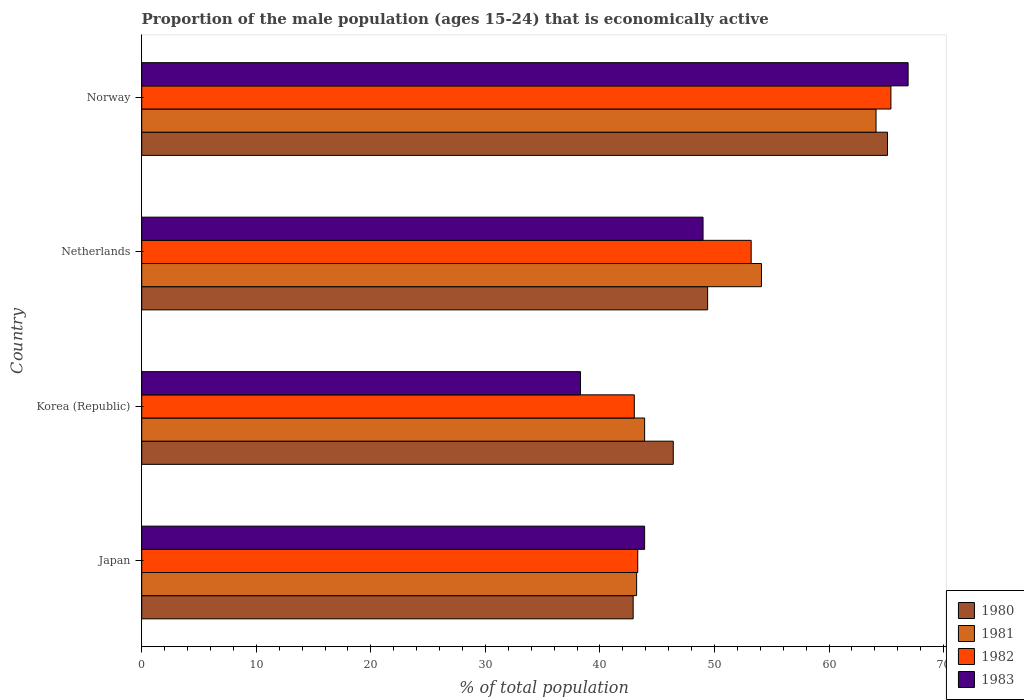How many groups of bars are there?
Keep it short and to the point. 4. How many bars are there on the 4th tick from the top?
Your answer should be compact. 4. How many bars are there on the 1st tick from the bottom?
Make the answer very short. 4. What is the label of the 4th group of bars from the top?
Offer a terse response. Japan. What is the proportion of the male population that is economically active in 1982 in Korea (Republic)?
Your answer should be very brief. 43. Across all countries, what is the maximum proportion of the male population that is economically active in 1983?
Offer a very short reply. 66.9. Across all countries, what is the minimum proportion of the male population that is economically active in 1982?
Offer a terse response. 43. In which country was the proportion of the male population that is economically active in 1980 maximum?
Your answer should be very brief. Norway. In which country was the proportion of the male population that is economically active in 1981 minimum?
Your answer should be very brief. Japan. What is the total proportion of the male population that is economically active in 1980 in the graph?
Make the answer very short. 203.8. What is the difference between the proportion of the male population that is economically active in 1982 in Japan and that in Netherlands?
Ensure brevity in your answer.  -9.9. What is the difference between the proportion of the male population that is economically active in 1983 in Korea (Republic) and the proportion of the male population that is economically active in 1980 in Netherlands?
Provide a short and direct response. -11.1. What is the average proportion of the male population that is economically active in 1983 per country?
Your answer should be very brief. 49.53. What is the difference between the proportion of the male population that is economically active in 1981 and proportion of the male population that is economically active in 1980 in Korea (Republic)?
Provide a succinct answer. -2.5. What is the ratio of the proportion of the male population that is economically active in 1981 in Japan to that in Korea (Republic)?
Your answer should be compact. 0.98. Is the difference between the proportion of the male population that is economically active in 1981 in Korea (Republic) and Norway greater than the difference between the proportion of the male population that is economically active in 1980 in Korea (Republic) and Norway?
Provide a succinct answer. No. What is the difference between the highest and the second highest proportion of the male population that is economically active in 1980?
Keep it short and to the point. 15.7. What is the difference between the highest and the lowest proportion of the male population that is economically active in 1981?
Ensure brevity in your answer.  20.9. Is the sum of the proportion of the male population that is economically active in 1981 in Korea (Republic) and Netherlands greater than the maximum proportion of the male population that is economically active in 1980 across all countries?
Your answer should be very brief. Yes. Is it the case that in every country, the sum of the proportion of the male population that is economically active in 1982 and proportion of the male population that is economically active in 1983 is greater than the sum of proportion of the male population that is economically active in 1981 and proportion of the male population that is economically active in 1980?
Offer a very short reply. No. What is the difference between two consecutive major ticks on the X-axis?
Keep it short and to the point. 10. Are the values on the major ticks of X-axis written in scientific E-notation?
Offer a terse response. No. Does the graph contain any zero values?
Offer a very short reply. No. Does the graph contain grids?
Provide a succinct answer. No. How are the legend labels stacked?
Offer a very short reply. Vertical. What is the title of the graph?
Your answer should be very brief. Proportion of the male population (ages 15-24) that is economically active. What is the label or title of the X-axis?
Keep it short and to the point. % of total population. What is the label or title of the Y-axis?
Provide a succinct answer. Country. What is the % of total population in 1980 in Japan?
Your answer should be compact. 42.9. What is the % of total population in 1981 in Japan?
Provide a succinct answer. 43.2. What is the % of total population in 1982 in Japan?
Provide a succinct answer. 43.3. What is the % of total population of 1983 in Japan?
Keep it short and to the point. 43.9. What is the % of total population of 1980 in Korea (Republic)?
Keep it short and to the point. 46.4. What is the % of total population of 1981 in Korea (Republic)?
Your answer should be very brief. 43.9. What is the % of total population in 1982 in Korea (Republic)?
Provide a short and direct response. 43. What is the % of total population in 1983 in Korea (Republic)?
Your response must be concise. 38.3. What is the % of total population of 1980 in Netherlands?
Provide a short and direct response. 49.4. What is the % of total population in 1981 in Netherlands?
Your answer should be compact. 54.1. What is the % of total population in 1982 in Netherlands?
Make the answer very short. 53.2. What is the % of total population of 1983 in Netherlands?
Provide a short and direct response. 49. What is the % of total population in 1980 in Norway?
Provide a short and direct response. 65.1. What is the % of total population in 1981 in Norway?
Keep it short and to the point. 64.1. What is the % of total population in 1982 in Norway?
Offer a very short reply. 65.4. What is the % of total population of 1983 in Norway?
Offer a terse response. 66.9. Across all countries, what is the maximum % of total population of 1980?
Offer a terse response. 65.1. Across all countries, what is the maximum % of total population of 1981?
Keep it short and to the point. 64.1. Across all countries, what is the maximum % of total population in 1982?
Make the answer very short. 65.4. Across all countries, what is the maximum % of total population in 1983?
Make the answer very short. 66.9. Across all countries, what is the minimum % of total population in 1980?
Ensure brevity in your answer.  42.9. Across all countries, what is the minimum % of total population of 1981?
Provide a succinct answer. 43.2. Across all countries, what is the minimum % of total population in 1982?
Give a very brief answer. 43. Across all countries, what is the minimum % of total population of 1983?
Provide a succinct answer. 38.3. What is the total % of total population in 1980 in the graph?
Your response must be concise. 203.8. What is the total % of total population in 1981 in the graph?
Offer a very short reply. 205.3. What is the total % of total population in 1982 in the graph?
Your response must be concise. 204.9. What is the total % of total population of 1983 in the graph?
Offer a very short reply. 198.1. What is the difference between the % of total population in 1980 in Japan and that in Korea (Republic)?
Give a very brief answer. -3.5. What is the difference between the % of total population in 1982 in Japan and that in Korea (Republic)?
Your answer should be very brief. 0.3. What is the difference between the % of total population of 1980 in Japan and that in Netherlands?
Make the answer very short. -6.5. What is the difference between the % of total population in 1981 in Japan and that in Netherlands?
Your answer should be very brief. -10.9. What is the difference between the % of total population of 1983 in Japan and that in Netherlands?
Provide a short and direct response. -5.1. What is the difference between the % of total population in 1980 in Japan and that in Norway?
Your response must be concise. -22.2. What is the difference between the % of total population in 1981 in Japan and that in Norway?
Give a very brief answer. -20.9. What is the difference between the % of total population in 1982 in Japan and that in Norway?
Offer a terse response. -22.1. What is the difference between the % of total population in 1983 in Japan and that in Norway?
Give a very brief answer. -23. What is the difference between the % of total population in 1980 in Korea (Republic) and that in Netherlands?
Your answer should be very brief. -3. What is the difference between the % of total population in 1980 in Korea (Republic) and that in Norway?
Ensure brevity in your answer.  -18.7. What is the difference between the % of total population of 1981 in Korea (Republic) and that in Norway?
Your response must be concise. -20.2. What is the difference between the % of total population of 1982 in Korea (Republic) and that in Norway?
Your response must be concise. -22.4. What is the difference between the % of total population of 1983 in Korea (Republic) and that in Norway?
Ensure brevity in your answer.  -28.6. What is the difference between the % of total population in 1980 in Netherlands and that in Norway?
Your answer should be very brief. -15.7. What is the difference between the % of total population in 1981 in Netherlands and that in Norway?
Provide a short and direct response. -10. What is the difference between the % of total population in 1982 in Netherlands and that in Norway?
Provide a short and direct response. -12.2. What is the difference between the % of total population in 1983 in Netherlands and that in Norway?
Your answer should be compact. -17.9. What is the difference between the % of total population in 1980 in Japan and the % of total population in 1982 in Korea (Republic)?
Ensure brevity in your answer.  -0.1. What is the difference between the % of total population of 1980 in Japan and the % of total population of 1981 in Netherlands?
Give a very brief answer. -11.2. What is the difference between the % of total population of 1980 in Japan and the % of total population of 1982 in Netherlands?
Give a very brief answer. -10.3. What is the difference between the % of total population of 1982 in Japan and the % of total population of 1983 in Netherlands?
Keep it short and to the point. -5.7. What is the difference between the % of total population of 1980 in Japan and the % of total population of 1981 in Norway?
Provide a short and direct response. -21.2. What is the difference between the % of total population in 1980 in Japan and the % of total population in 1982 in Norway?
Your response must be concise. -22.5. What is the difference between the % of total population in 1981 in Japan and the % of total population in 1982 in Norway?
Your response must be concise. -22.2. What is the difference between the % of total population of 1981 in Japan and the % of total population of 1983 in Norway?
Your response must be concise. -23.7. What is the difference between the % of total population in 1982 in Japan and the % of total population in 1983 in Norway?
Your response must be concise. -23.6. What is the difference between the % of total population in 1980 in Korea (Republic) and the % of total population in 1981 in Netherlands?
Provide a succinct answer. -7.7. What is the difference between the % of total population in 1980 in Korea (Republic) and the % of total population in 1982 in Netherlands?
Keep it short and to the point. -6.8. What is the difference between the % of total population in 1981 in Korea (Republic) and the % of total population in 1982 in Netherlands?
Your answer should be very brief. -9.3. What is the difference between the % of total population in 1982 in Korea (Republic) and the % of total population in 1983 in Netherlands?
Keep it short and to the point. -6. What is the difference between the % of total population of 1980 in Korea (Republic) and the % of total population of 1981 in Norway?
Keep it short and to the point. -17.7. What is the difference between the % of total population of 1980 in Korea (Republic) and the % of total population of 1983 in Norway?
Provide a succinct answer. -20.5. What is the difference between the % of total population of 1981 in Korea (Republic) and the % of total population of 1982 in Norway?
Make the answer very short. -21.5. What is the difference between the % of total population in 1982 in Korea (Republic) and the % of total population in 1983 in Norway?
Offer a terse response. -23.9. What is the difference between the % of total population in 1980 in Netherlands and the % of total population in 1981 in Norway?
Ensure brevity in your answer.  -14.7. What is the difference between the % of total population of 1980 in Netherlands and the % of total population of 1982 in Norway?
Your answer should be very brief. -16. What is the difference between the % of total population of 1980 in Netherlands and the % of total population of 1983 in Norway?
Ensure brevity in your answer.  -17.5. What is the difference between the % of total population in 1982 in Netherlands and the % of total population in 1983 in Norway?
Your answer should be compact. -13.7. What is the average % of total population of 1980 per country?
Offer a terse response. 50.95. What is the average % of total population in 1981 per country?
Your answer should be very brief. 51.33. What is the average % of total population of 1982 per country?
Your response must be concise. 51.23. What is the average % of total population in 1983 per country?
Provide a succinct answer. 49.52. What is the difference between the % of total population of 1980 and % of total population of 1981 in Japan?
Provide a short and direct response. -0.3. What is the difference between the % of total population in 1980 and % of total population in 1982 in Japan?
Provide a succinct answer. -0.4. What is the difference between the % of total population in 1980 and % of total population in 1983 in Japan?
Ensure brevity in your answer.  -1. What is the difference between the % of total population of 1981 and % of total population of 1982 in Japan?
Make the answer very short. -0.1. What is the difference between the % of total population in 1980 and % of total population in 1981 in Korea (Republic)?
Give a very brief answer. 2.5. What is the difference between the % of total population of 1980 and % of total population of 1983 in Korea (Republic)?
Provide a succinct answer. 8.1. What is the difference between the % of total population of 1981 and % of total population of 1983 in Korea (Republic)?
Give a very brief answer. 5.6. What is the difference between the % of total population of 1982 and % of total population of 1983 in Korea (Republic)?
Provide a succinct answer. 4.7. What is the difference between the % of total population of 1980 and % of total population of 1983 in Netherlands?
Offer a very short reply. 0.4. What is the difference between the % of total population of 1981 and % of total population of 1983 in Netherlands?
Provide a succinct answer. 5.1. What is the difference between the % of total population in 1980 and % of total population in 1983 in Norway?
Provide a short and direct response. -1.8. What is the difference between the % of total population of 1981 and % of total population of 1983 in Norway?
Keep it short and to the point. -2.8. What is the ratio of the % of total population of 1980 in Japan to that in Korea (Republic)?
Offer a terse response. 0.92. What is the ratio of the % of total population in 1981 in Japan to that in Korea (Republic)?
Provide a short and direct response. 0.98. What is the ratio of the % of total population in 1982 in Japan to that in Korea (Republic)?
Make the answer very short. 1.01. What is the ratio of the % of total population of 1983 in Japan to that in Korea (Republic)?
Offer a terse response. 1.15. What is the ratio of the % of total population of 1980 in Japan to that in Netherlands?
Your response must be concise. 0.87. What is the ratio of the % of total population of 1981 in Japan to that in Netherlands?
Offer a very short reply. 0.8. What is the ratio of the % of total population of 1982 in Japan to that in Netherlands?
Ensure brevity in your answer.  0.81. What is the ratio of the % of total population of 1983 in Japan to that in Netherlands?
Give a very brief answer. 0.9. What is the ratio of the % of total population in 1980 in Japan to that in Norway?
Keep it short and to the point. 0.66. What is the ratio of the % of total population of 1981 in Japan to that in Norway?
Keep it short and to the point. 0.67. What is the ratio of the % of total population in 1982 in Japan to that in Norway?
Make the answer very short. 0.66. What is the ratio of the % of total population in 1983 in Japan to that in Norway?
Ensure brevity in your answer.  0.66. What is the ratio of the % of total population of 1980 in Korea (Republic) to that in Netherlands?
Offer a very short reply. 0.94. What is the ratio of the % of total population of 1981 in Korea (Republic) to that in Netherlands?
Ensure brevity in your answer.  0.81. What is the ratio of the % of total population in 1982 in Korea (Republic) to that in Netherlands?
Offer a very short reply. 0.81. What is the ratio of the % of total population of 1983 in Korea (Republic) to that in Netherlands?
Ensure brevity in your answer.  0.78. What is the ratio of the % of total population in 1980 in Korea (Republic) to that in Norway?
Offer a terse response. 0.71. What is the ratio of the % of total population of 1981 in Korea (Republic) to that in Norway?
Offer a very short reply. 0.68. What is the ratio of the % of total population in 1982 in Korea (Republic) to that in Norway?
Offer a terse response. 0.66. What is the ratio of the % of total population in 1983 in Korea (Republic) to that in Norway?
Your answer should be very brief. 0.57. What is the ratio of the % of total population of 1980 in Netherlands to that in Norway?
Your answer should be compact. 0.76. What is the ratio of the % of total population of 1981 in Netherlands to that in Norway?
Offer a very short reply. 0.84. What is the ratio of the % of total population of 1982 in Netherlands to that in Norway?
Make the answer very short. 0.81. What is the ratio of the % of total population of 1983 in Netherlands to that in Norway?
Ensure brevity in your answer.  0.73. What is the difference between the highest and the second highest % of total population of 1980?
Your answer should be very brief. 15.7. What is the difference between the highest and the second highest % of total population of 1981?
Provide a succinct answer. 10. What is the difference between the highest and the second highest % of total population in 1982?
Provide a succinct answer. 12.2. What is the difference between the highest and the second highest % of total population in 1983?
Provide a succinct answer. 17.9. What is the difference between the highest and the lowest % of total population of 1980?
Offer a terse response. 22.2. What is the difference between the highest and the lowest % of total population of 1981?
Keep it short and to the point. 20.9. What is the difference between the highest and the lowest % of total population of 1982?
Provide a succinct answer. 22.4. What is the difference between the highest and the lowest % of total population of 1983?
Provide a succinct answer. 28.6. 